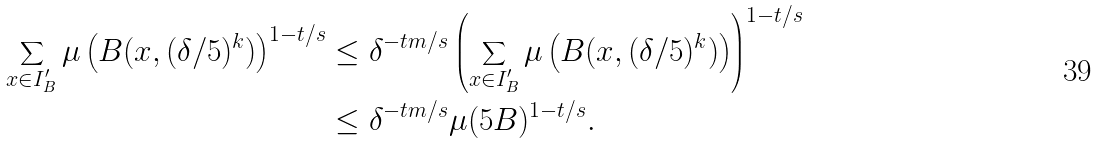<formula> <loc_0><loc_0><loc_500><loc_500>\sum _ { x \in I _ { B } ^ { \prime } } \mu \left ( B ( x , ( \delta / 5 ) ^ { k } ) \right ) ^ { 1 - t / s } & \leq \delta ^ { - t m / s } \left ( \sum _ { x \in I _ { B } ^ { \prime } } \mu \left ( B ( x , ( \delta / 5 ) ^ { k } ) \right ) \right ) ^ { 1 - t / s } \\ & \leq \delta ^ { - t m / s } \mu ( 5 B ) ^ { 1 - t / s } .</formula> 